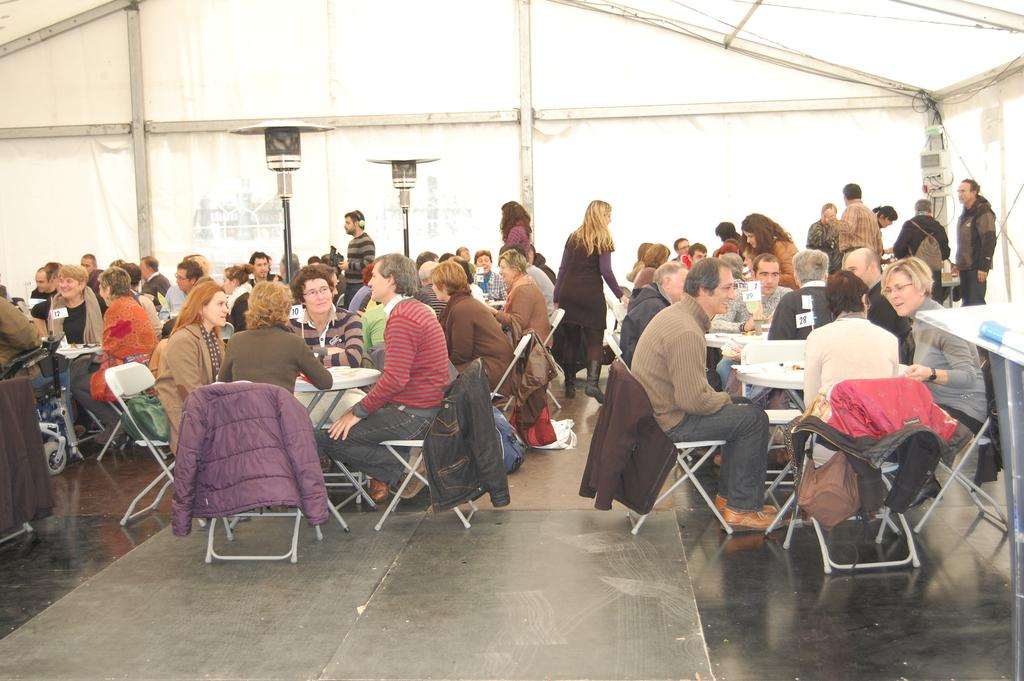What type of establishment is the image taken in? The image appears to be taken in a restaurant. What can be seen in the background of the image? There is a tent in the background of the image. Where is the table located in the image? There is a table on the right side of the image. What furniture and people can be seen throughout the image? Tables, chairs, and people seated are present throughout the image. What type of sign is the governor holding in the image? There is no governor or sign present in the image. 